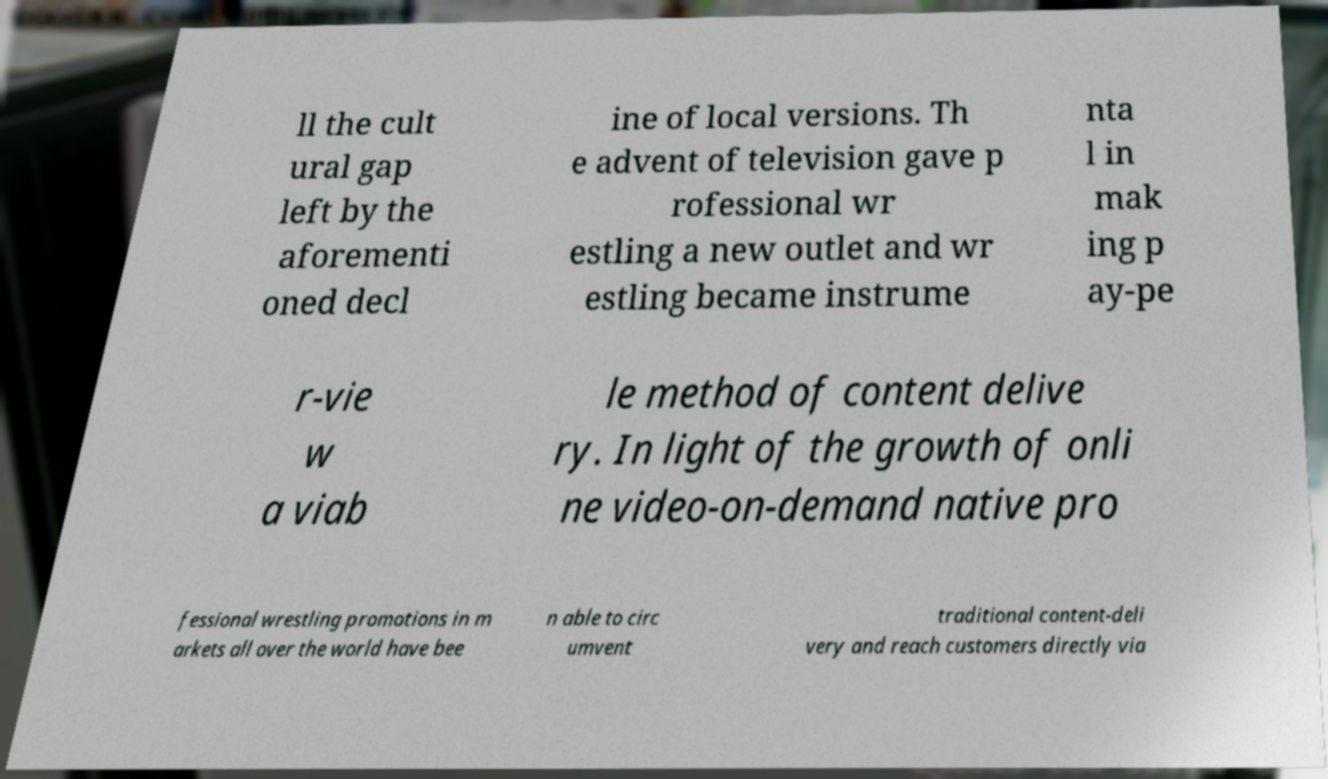Can you accurately transcribe the text from the provided image for me? ll the cult ural gap left by the aforementi oned decl ine of local versions. Th e advent of television gave p rofessional wr estling a new outlet and wr estling became instrume nta l in mak ing p ay-pe r-vie w a viab le method of content delive ry. In light of the growth of onli ne video-on-demand native pro fessional wrestling promotions in m arkets all over the world have bee n able to circ umvent traditional content-deli very and reach customers directly via 